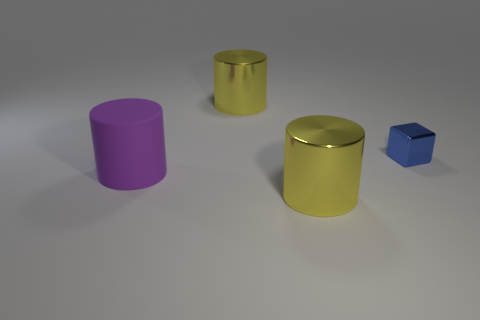Subtract all yellow cylinders. How many cylinders are left? 1 Subtract all yellow spheres. How many yellow cylinders are left? 2 Subtract 1 cylinders. How many cylinders are left? 2 Add 2 tiny blue metallic things. How many objects exist? 6 Subtract 0 red cylinders. How many objects are left? 4 Subtract all cylinders. How many objects are left? 1 Subtract all blue cylinders. Subtract all cyan blocks. How many cylinders are left? 3 Subtract all big red cylinders. Subtract all large yellow metal cylinders. How many objects are left? 2 Add 1 blue objects. How many blue objects are left? 2 Add 2 big rubber objects. How many big rubber objects exist? 3 